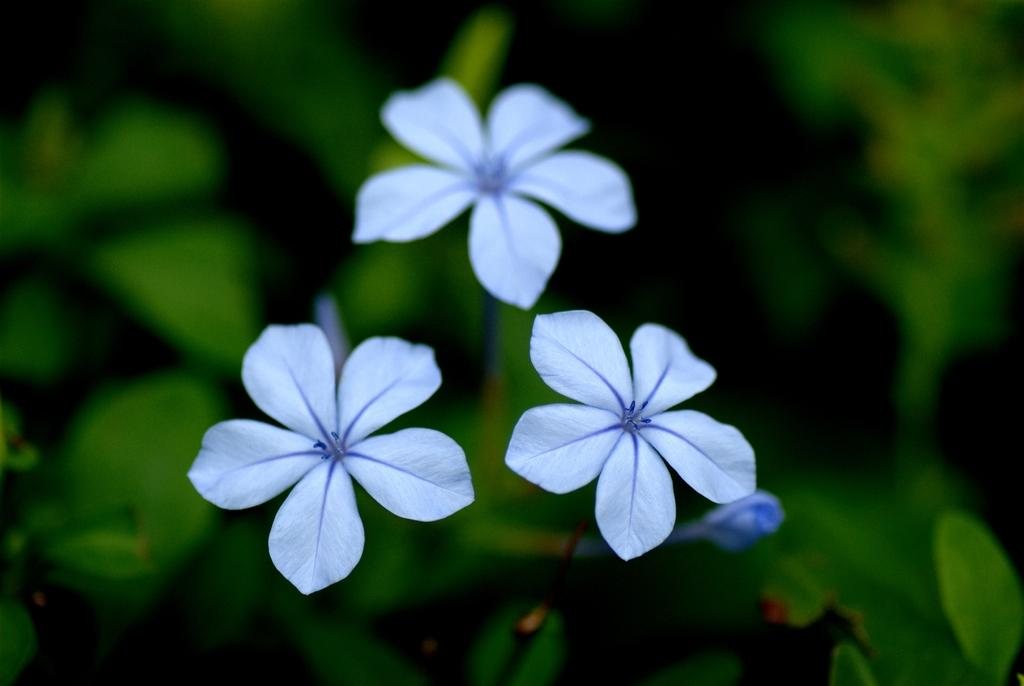What type of living organisms can be seen in the image? Plants can be seen in the image. What specific feature of the plants is visible in the image? The plants have flowers on them. What type of education can be seen in the image? There is no reference to education in the image; it features plants with flowers. What color is the curtain in the image? There is no curtain present in the image. 